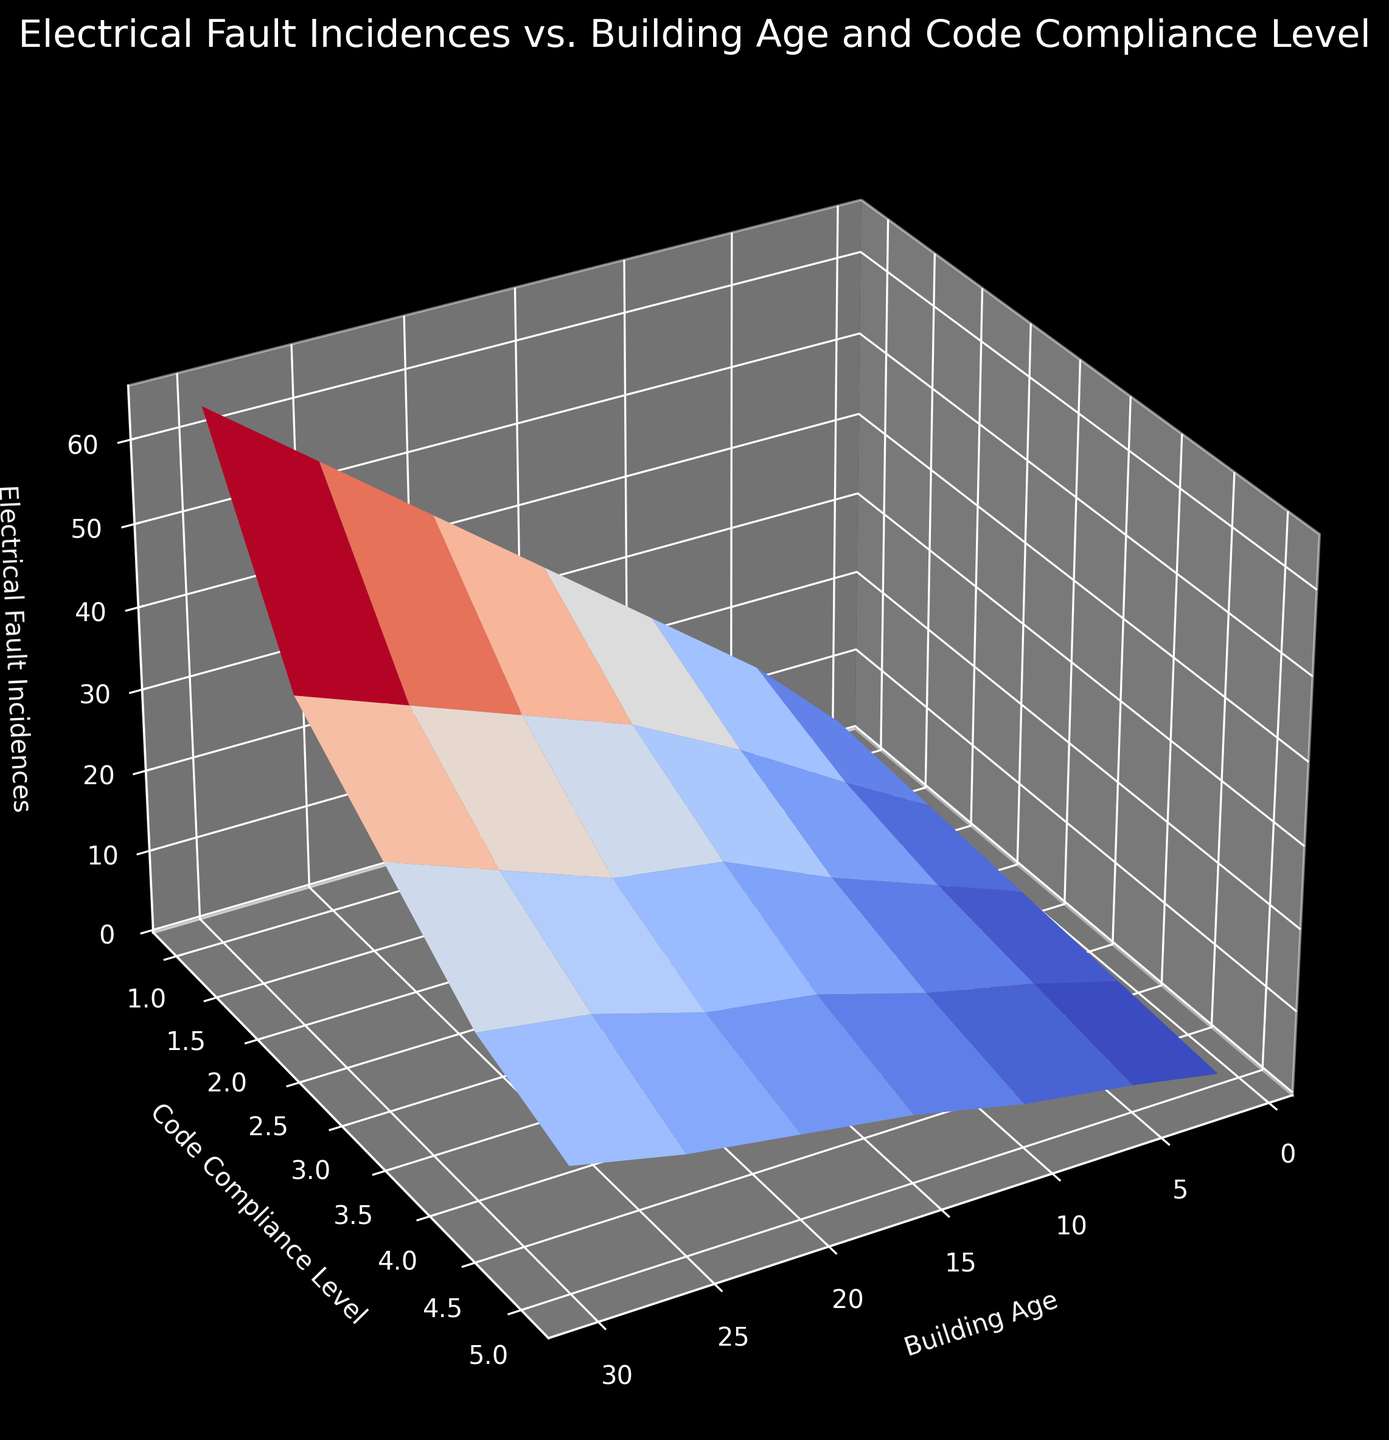What is the trend in electrical fault incidences as the building age increases for the highest code compliance level? For the highest code compliance level (5), as the building age increases, the electrical fault incidences also increase. Starting from 1 fault incidence for buildings aged 1 year to 15 fault incidences for buildings aged 30 years.
Answer: Increase At which building age do electrical fault incidences show the highest value for code compliance level 1? For code compliance level 1, electrical fault incidences are highest for buildings aged 30 years, reaching 65 incidences.
Answer: 30 years How does the number of electrical fault incidences change from code compliance level 1 to level 5 for a 15-year-old building? For a 15-year-old building, the electrical fault incidences decrease as code compliance levels increase. Starting from 35 incidences at level 1, down to 8 at level 5.
Answer: Decrease What is the average number of electrical fault incidences for code compliance level 3 across all building ages? The number of electrical fault incidences for code compliance level 3 at different ages (1, 5, 10, 15, 20, 25, and 30 years) are 3, 7, 12, 18, 20, 25, and 30, respectively. Summing these up gives 115, and there are 7 data points, so the average is 115/7.
Answer: 16.43 Compare the electrical fault incidences for a building aged 10 years at code compliance levels 2 and 4. For a building aged 10 years, the electrical fault incidences are 18 at code compliance level 2 and 8 at level 4. Level 2 has more incidences.
Answer: Level 2 has more What is the general visual shape of the surface plot when comparing electrical fault incidences across buildings with different ages and code compliance levels? The surface plot typically forms a declining slope when moving from code compliance level 1 to level 5 across any given building age. The fault incidences tend to increase as the building age increases. This results in a roughly declining plane from bottom (youngest age, highest compliance) to top (oldest age, lowest compliance).
Answer: Declining slope If you were to maintain strict electrical codes, which age group of buildings would benefit the most in terms of reducing electrical fault incidences? Buildings in the highest age group (30 years) would benefit the most since stricter compliance levels correlate with higher reduction in fault incidences. At compliance level 5, incidences drop from 65 to 15.
Answer: 30 years Which code compliance level shows the least variation in electrical fault incidences across different building ages? Code compliance level 5 shows the least variation, ranging from 1 incidence in a 1-year-old building to 15 incidences in a 30-year-old building. The range is 14 incidences compared to larger ranges in other levels.
Answer: Level 5 